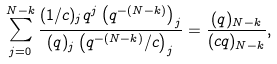Convert formula to latex. <formula><loc_0><loc_0><loc_500><loc_500>\sum _ { j = 0 } ^ { N - k } \frac { ( 1 / c ) _ { j } q ^ { j } \left ( q ^ { - ( N - k ) } \right ) _ { j } } { ( q ) _ { j } \left ( q ^ { - ( N - k ) } / c \right ) _ { j } } = \frac { ( q ) _ { N - k } } { ( c q ) _ { N - k } } ,</formula> 